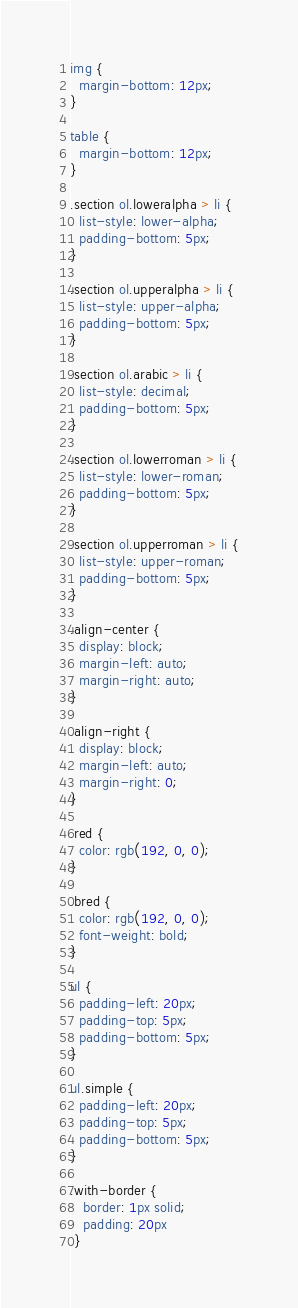<code> <loc_0><loc_0><loc_500><loc_500><_CSS_>img {
  margin-bottom: 12px;
}

table {
  margin-bottom: 12px;
}

.section ol.loweralpha > li { 
  list-style: lower-alpha;
  padding-bottom: 5px;
}

.section ol.upperalpha > li { 
  list-style: upper-alpha;
  padding-bottom: 5px;
}

.section ol.arabic > li {
  list-style: decimal;
  padding-bottom: 5px;
}

.section ol.lowerroman > li {
  list-style: lower-roman;
  padding-bottom: 5px;
}

.section ol.upperroman > li {
  list-style: upper-roman;
  padding-bottom: 5px;
}

.align-center {
  display: block;
  margin-left: auto;
  margin-right: auto;
}

.align-right {
  display: block;
  margin-left: auto;
  margin-right: 0;
}

.red {
  color: rgb(192, 0, 0);
}

.bred {
  color: rgb(192, 0, 0);
  font-weight: bold;
}

ul {
  padding-left: 20px;
  padding-top: 5px;
  padding-bottom: 5px;
}

ul.simple {
  padding-left: 20px;
  padding-top: 5px;
  padding-bottom: 5px;
}

.with-border {
   border: 1px solid;
   padding: 20px
 }
</code> 